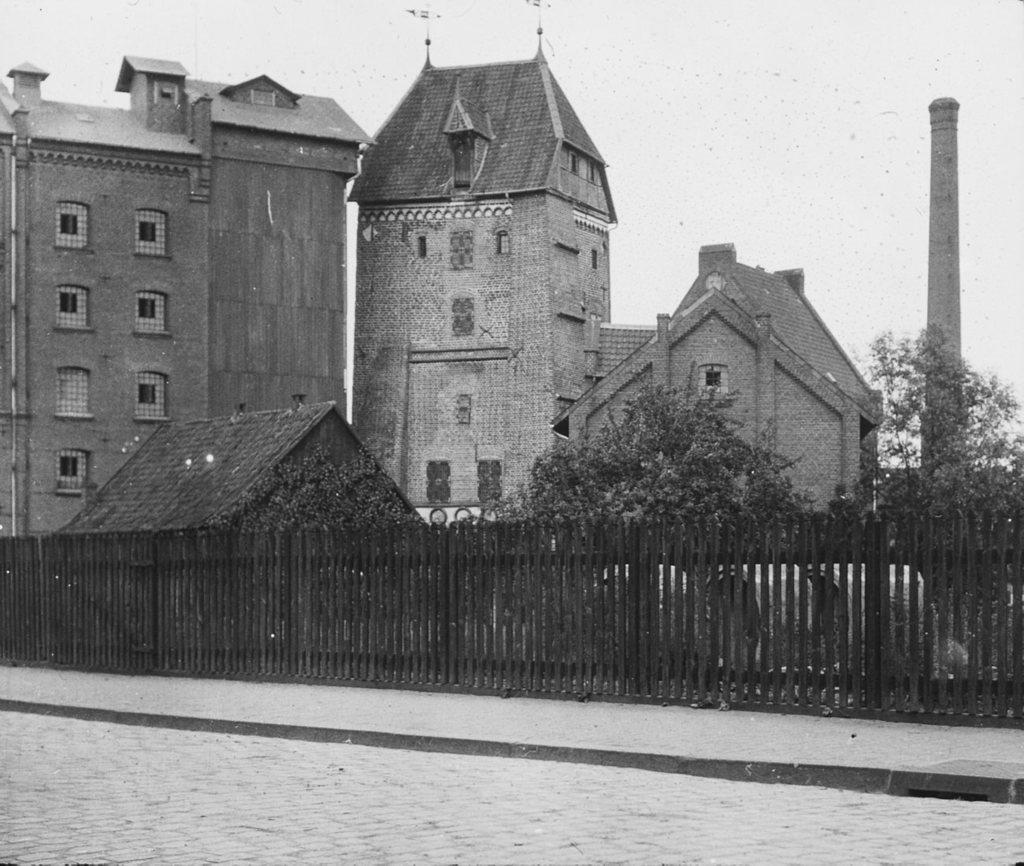Please provide a concise description of this image. This is a black and white picture. At the of the picture, we see a road. Beside that, we see a picket fence. There are buildings and trees. On the right side, we see a monument. 